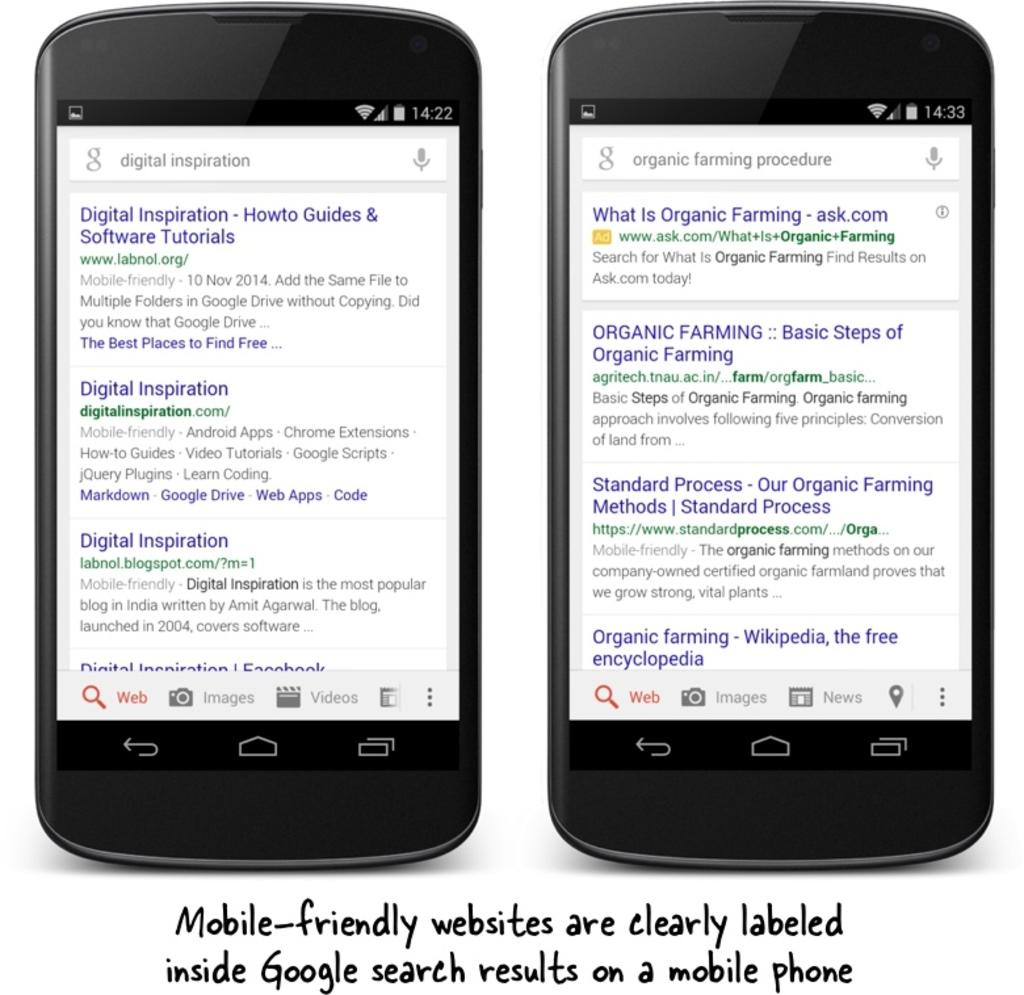<image>
Summarize the visual content of the image. Google search results are mobile friendly on two black smartphones 